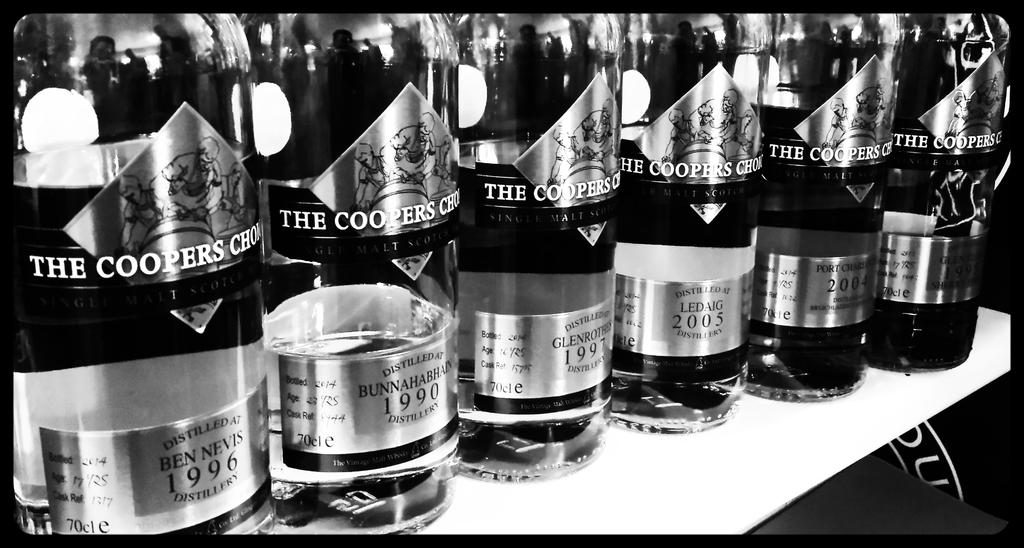Provide a one-sentence caption for the provided image. Several bottles of alcohol with dates including 1990 and 1997 are lined up. 